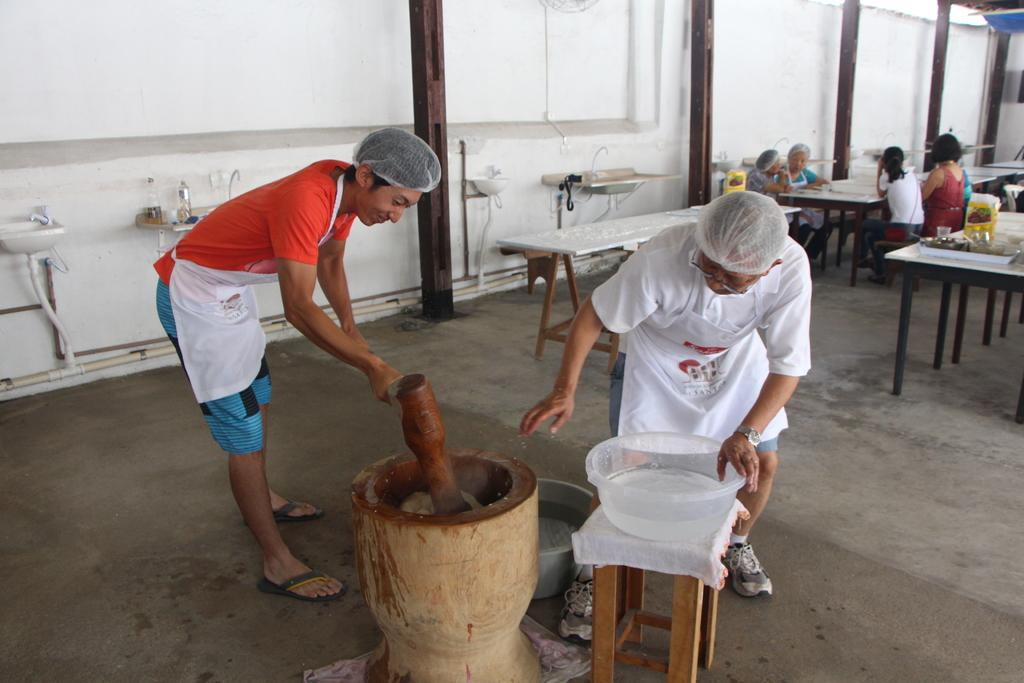What is happening at the right side of the image? There is a group of persons sitting at the right side of the image. What can be seen in the middle of the image? There are two persons in the middle of the image. What are the two persons in the middle doing? The two persons in the middle are doing some work. What type of suit is the hydrant wearing in the image? There is no hydrant present in the image, and therefore no suit can be observed. Can you describe the curve of the work being done by the two persons in the middle? The provided facts do not mention any curves or specific shapes related to the work being done by the two persons in the middle. 